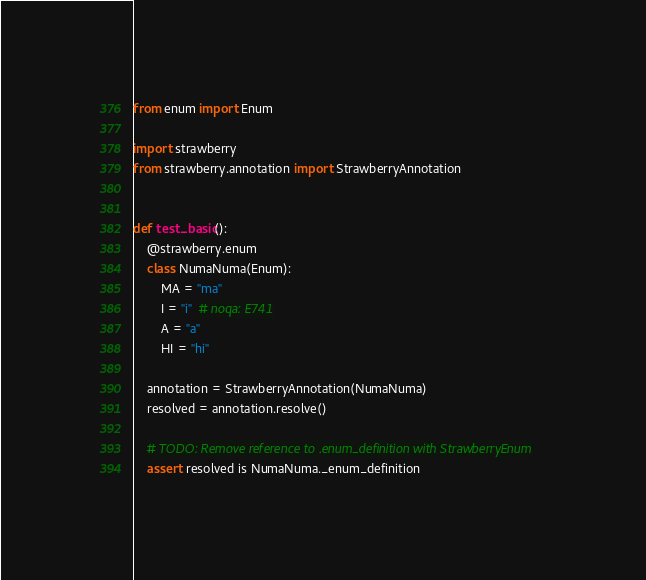Convert code to text. <code><loc_0><loc_0><loc_500><loc_500><_Python_>from enum import Enum

import strawberry
from strawberry.annotation import StrawberryAnnotation


def test_basic():
    @strawberry.enum
    class NumaNuma(Enum):
        MA = "ma"
        I = "i"  # noqa: E741
        A = "a"
        HI = "hi"

    annotation = StrawberryAnnotation(NumaNuma)
    resolved = annotation.resolve()

    # TODO: Remove reference to .enum_definition with StrawberryEnum
    assert resolved is NumaNuma._enum_definition
</code> 